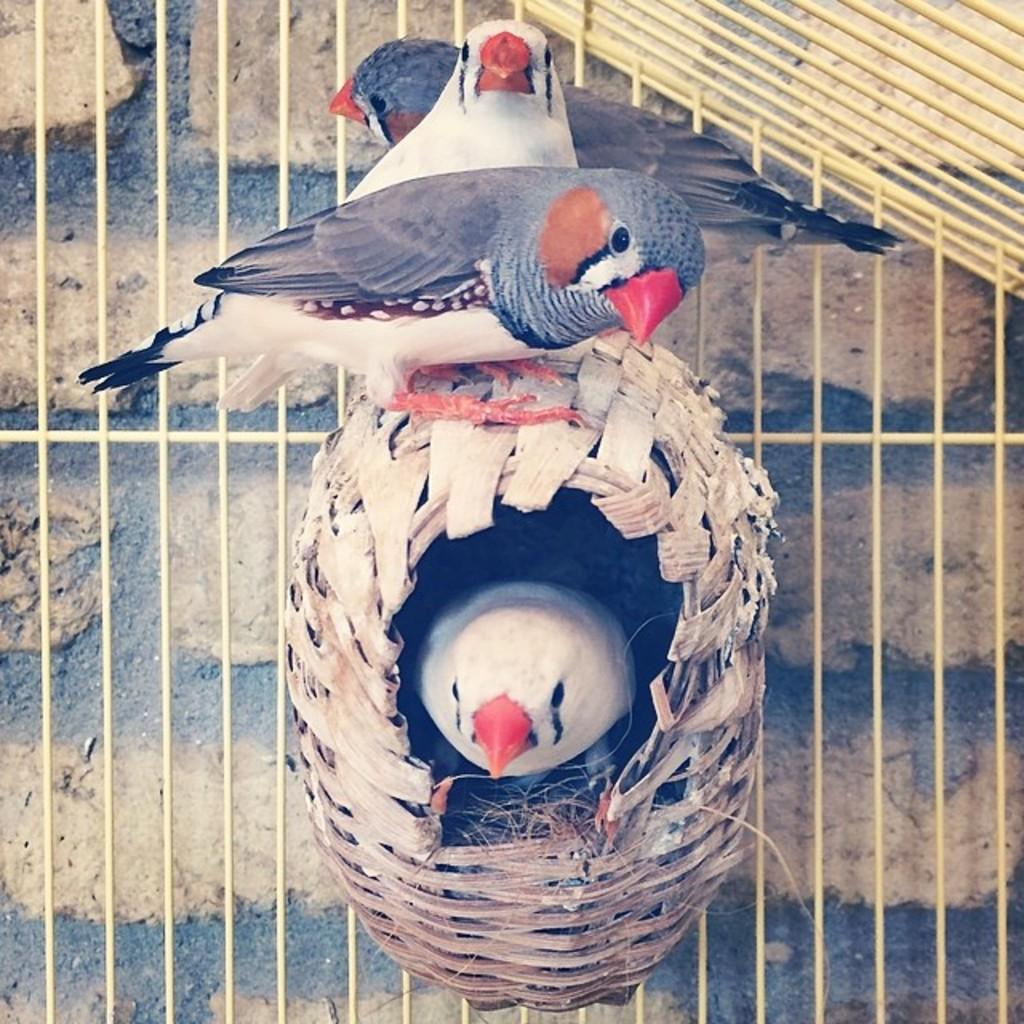What type of animals can be seen in the image? There are birds in the image. What are the birds doing in the image? Some birds are standing on a nest, and one bird is inside the nest. What color is the cow's tail in the image? There is no cow present in the image, so there is no tail to describe. 